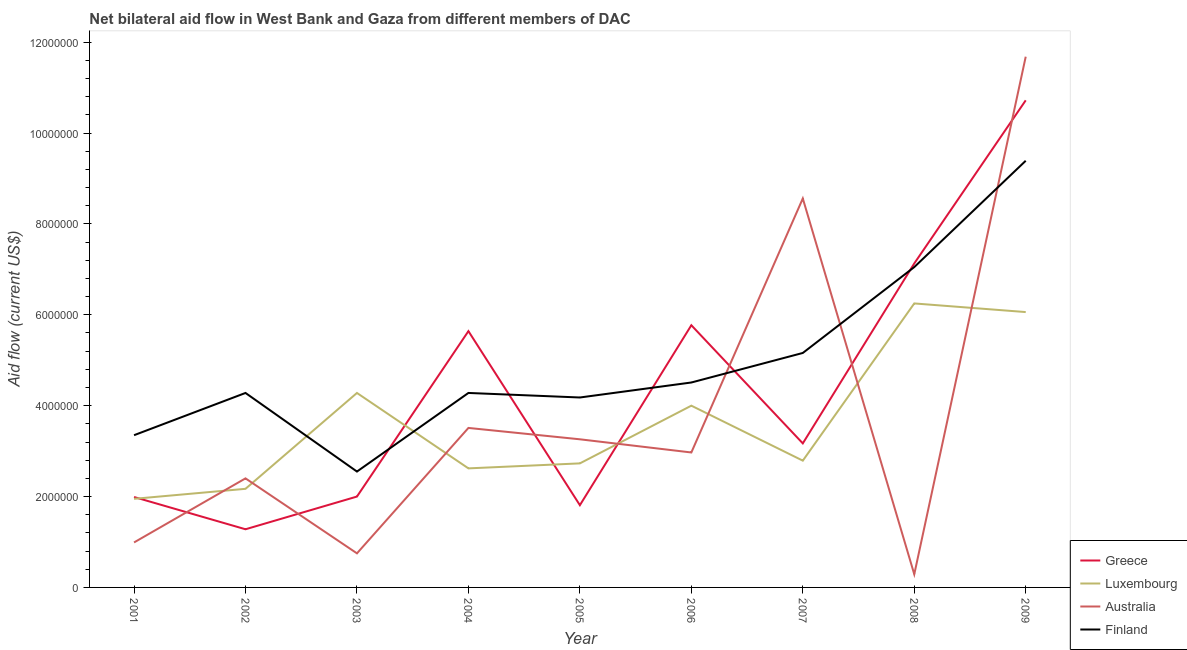How many different coloured lines are there?
Offer a terse response. 4. Does the line corresponding to amount of aid given by australia intersect with the line corresponding to amount of aid given by finland?
Offer a very short reply. Yes. What is the amount of aid given by greece in 2003?
Make the answer very short. 2.00e+06. Across all years, what is the maximum amount of aid given by australia?
Ensure brevity in your answer.  1.17e+07. Across all years, what is the minimum amount of aid given by finland?
Provide a succinct answer. 2.55e+06. In which year was the amount of aid given by finland minimum?
Offer a terse response. 2003. What is the total amount of aid given by australia in the graph?
Provide a succinct answer. 3.44e+07. What is the difference between the amount of aid given by finland in 2005 and that in 2007?
Keep it short and to the point. -9.80e+05. What is the difference between the amount of aid given by luxembourg in 2002 and the amount of aid given by greece in 2003?
Your answer should be very brief. 1.70e+05. What is the average amount of aid given by greece per year?
Offer a terse response. 4.39e+06. In the year 2009, what is the difference between the amount of aid given by finland and amount of aid given by greece?
Offer a very short reply. -1.33e+06. What is the ratio of the amount of aid given by finland in 2003 to that in 2008?
Give a very brief answer. 0.36. Is the amount of aid given by australia in 2004 less than that in 2009?
Provide a short and direct response. Yes. Is the difference between the amount of aid given by finland in 2002 and 2007 greater than the difference between the amount of aid given by australia in 2002 and 2007?
Your answer should be very brief. Yes. What is the difference between the highest and the second highest amount of aid given by luxembourg?
Your response must be concise. 1.90e+05. What is the difference between the highest and the lowest amount of aid given by greece?
Ensure brevity in your answer.  9.44e+06. Is it the case that in every year, the sum of the amount of aid given by greece and amount of aid given by luxembourg is greater than the amount of aid given by australia?
Your response must be concise. No. Is the amount of aid given by australia strictly greater than the amount of aid given by luxembourg over the years?
Provide a succinct answer. No. Is the amount of aid given by luxembourg strictly less than the amount of aid given by australia over the years?
Your answer should be compact. No. What is the difference between two consecutive major ticks on the Y-axis?
Offer a terse response. 2.00e+06. How many legend labels are there?
Ensure brevity in your answer.  4. How are the legend labels stacked?
Keep it short and to the point. Vertical. What is the title of the graph?
Ensure brevity in your answer.  Net bilateral aid flow in West Bank and Gaza from different members of DAC. What is the Aid flow (current US$) in Greece in 2001?
Provide a short and direct response. 1.99e+06. What is the Aid flow (current US$) in Luxembourg in 2001?
Offer a terse response. 1.95e+06. What is the Aid flow (current US$) of Australia in 2001?
Offer a very short reply. 9.90e+05. What is the Aid flow (current US$) in Finland in 2001?
Provide a succinct answer. 3.35e+06. What is the Aid flow (current US$) of Greece in 2002?
Provide a short and direct response. 1.28e+06. What is the Aid flow (current US$) of Luxembourg in 2002?
Keep it short and to the point. 2.17e+06. What is the Aid flow (current US$) in Australia in 2002?
Keep it short and to the point. 2.40e+06. What is the Aid flow (current US$) of Finland in 2002?
Keep it short and to the point. 4.28e+06. What is the Aid flow (current US$) of Luxembourg in 2003?
Your answer should be very brief. 4.28e+06. What is the Aid flow (current US$) in Australia in 2003?
Provide a succinct answer. 7.50e+05. What is the Aid flow (current US$) of Finland in 2003?
Your answer should be compact. 2.55e+06. What is the Aid flow (current US$) of Greece in 2004?
Your answer should be compact. 5.64e+06. What is the Aid flow (current US$) of Luxembourg in 2004?
Your answer should be compact. 2.62e+06. What is the Aid flow (current US$) in Australia in 2004?
Make the answer very short. 3.51e+06. What is the Aid flow (current US$) of Finland in 2004?
Ensure brevity in your answer.  4.28e+06. What is the Aid flow (current US$) of Greece in 2005?
Give a very brief answer. 1.81e+06. What is the Aid flow (current US$) in Luxembourg in 2005?
Your response must be concise. 2.73e+06. What is the Aid flow (current US$) in Australia in 2005?
Provide a succinct answer. 3.26e+06. What is the Aid flow (current US$) of Finland in 2005?
Give a very brief answer. 4.18e+06. What is the Aid flow (current US$) of Greece in 2006?
Provide a short and direct response. 5.77e+06. What is the Aid flow (current US$) in Luxembourg in 2006?
Provide a succinct answer. 4.00e+06. What is the Aid flow (current US$) of Australia in 2006?
Give a very brief answer. 2.97e+06. What is the Aid flow (current US$) of Finland in 2006?
Your answer should be compact. 4.51e+06. What is the Aid flow (current US$) of Greece in 2007?
Give a very brief answer. 3.17e+06. What is the Aid flow (current US$) of Luxembourg in 2007?
Offer a terse response. 2.79e+06. What is the Aid flow (current US$) of Australia in 2007?
Keep it short and to the point. 8.56e+06. What is the Aid flow (current US$) of Finland in 2007?
Provide a succinct answer. 5.16e+06. What is the Aid flow (current US$) in Greece in 2008?
Your response must be concise. 7.13e+06. What is the Aid flow (current US$) of Luxembourg in 2008?
Keep it short and to the point. 6.25e+06. What is the Aid flow (current US$) of Finland in 2008?
Your response must be concise. 7.05e+06. What is the Aid flow (current US$) of Greece in 2009?
Ensure brevity in your answer.  1.07e+07. What is the Aid flow (current US$) in Luxembourg in 2009?
Make the answer very short. 6.06e+06. What is the Aid flow (current US$) in Australia in 2009?
Give a very brief answer. 1.17e+07. What is the Aid flow (current US$) in Finland in 2009?
Keep it short and to the point. 9.39e+06. Across all years, what is the maximum Aid flow (current US$) of Greece?
Your response must be concise. 1.07e+07. Across all years, what is the maximum Aid flow (current US$) of Luxembourg?
Provide a succinct answer. 6.25e+06. Across all years, what is the maximum Aid flow (current US$) in Australia?
Your response must be concise. 1.17e+07. Across all years, what is the maximum Aid flow (current US$) in Finland?
Your response must be concise. 9.39e+06. Across all years, what is the minimum Aid flow (current US$) of Greece?
Your response must be concise. 1.28e+06. Across all years, what is the minimum Aid flow (current US$) in Luxembourg?
Provide a short and direct response. 1.95e+06. Across all years, what is the minimum Aid flow (current US$) of Finland?
Your answer should be compact. 2.55e+06. What is the total Aid flow (current US$) in Greece in the graph?
Your answer should be compact. 3.95e+07. What is the total Aid flow (current US$) in Luxembourg in the graph?
Make the answer very short. 3.28e+07. What is the total Aid flow (current US$) in Australia in the graph?
Your answer should be compact. 3.44e+07. What is the total Aid flow (current US$) of Finland in the graph?
Ensure brevity in your answer.  4.48e+07. What is the difference between the Aid flow (current US$) of Greece in 2001 and that in 2002?
Give a very brief answer. 7.10e+05. What is the difference between the Aid flow (current US$) in Luxembourg in 2001 and that in 2002?
Ensure brevity in your answer.  -2.20e+05. What is the difference between the Aid flow (current US$) in Australia in 2001 and that in 2002?
Offer a terse response. -1.41e+06. What is the difference between the Aid flow (current US$) of Finland in 2001 and that in 2002?
Keep it short and to the point. -9.30e+05. What is the difference between the Aid flow (current US$) in Luxembourg in 2001 and that in 2003?
Give a very brief answer. -2.33e+06. What is the difference between the Aid flow (current US$) in Greece in 2001 and that in 2004?
Your answer should be very brief. -3.65e+06. What is the difference between the Aid flow (current US$) of Luxembourg in 2001 and that in 2004?
Provide a succinct answer. -6.70e+05. What is the difference between the Aid flow (current US$) in Australia in 2001 and that in 2004?
Ensure brevity in your answer.  -2.52e+06. What is the difference between the Aid flow (current US$) in Finland in 2001 and that in 2004?
Provide a short and direct response. -9.30e+05. What is the difference between the Aid flow (current US$) in Greece in 2001 and that in 2005?
Make the answer very short. 1.80e+05. What is the difference between the Aid flow (current US$) of Luxembourg in 2001 and that in 2005?
Provide a succinct answer. -7.80e+05. What is the difference between the Aid flow (current US$) in Australia in 2001 and that in 2005?
Ensure brevity in your answer.  -2.27e+06. What is the difference between the Aid flow (current US$) of Finland in 2001 and that in 2005?
Ensure brevity in your answer.  -8.30e+05. What is the difference between the Aid flow (current US$) of Greece in 2001 and that in 2006?
Offer a very short reply. -3.78e+06. What is the difference between the Aid flow (current US$) in Luxembourg in 2001 and that in 2006?
Give a very brief answer. -2.05e+06. What is the difference between the Aid flow (current US$) in Australia in 2001 and that in 2006?
Keep it short and to the point. -1.98e+06. What is the difference between the Aid flow (current US$) of Finland in 2001 and that in 2006?
Make the answer very short. -1.16e+06. What is the difference between the Aid flow (current US$) of Greece in 2001 and that in 2007?
Your response must be concise. -1.18e+06. What is the difference between the Aid flow (current US$) in Luxembourg in 2001 and that in 2007?
Your response must be concise. -8.40e+05. What is the difference between the Aid flow (current US$) in Australia in 2001 and that in 2007?
Your answer should be very brief. -7.57e+06. What is the difference between the Aid flow (current US$) in Finland in 2001 and that in 2007?
Offer a terse response. -1.81e+06. What is the difference between the Aid flow (current US$) of Greece in 2001 and that in 2008?
Offer a very short reply. -5.14e+06. What is the difference between the Aid flow (current US$) of Luxembourg in 2001 and that in 2008?
Offer a terse response. -4.30e+06. What is the difference between the Aid flow (current US$) of Finland in 2001 and that in 2008?
Your response must be concise. -3.70e+06. What is the difference between the Aid flow (current US$) in Greece in 2001 and that in 2009?
Provide a succinct answer. -8.73e+06. What is the difference between the Aid flow (current US$) of Luxembourg in 2001 and that in 2009?
Your response must be concise. -4.11e+06. What is the difference between the Aid flow (current US$) of Australia in 2001 and that in 2009?
Provide a short and direct response. -1.07e+07. What is the difference between the Aid flow (current US$) of Finland in 2001 and that in 2009?
Keep it short and to the point. -6.04e+06. What is the difference between the Aid flow (current US$) in Greece in 2002 and that in 2003?
Offer a terse response. -7.20e+05. What is the difference between the Aid flow (current US$) in Luxembourg in 2002 and that in 2003?
Make the answer very short. -2.11e+06. What is the difference between the Aid flow (current US$) in Australia in 2002 and that in 2003?
Provide a succinct answer. 1.65e+06. What is the difference between the Aid flow (current US$) in Finland in 2002 and that in 2003?
Keep it short and to the point. 1.73e+06. What is the difference between the Aid flow (current US$) of Greece in 2002 and that in 2004?
Your answer should be very brief. -4.36e+06. What is the difference between the Aid flow (current US$) of Luxembourg in 2002 and that in 2004?
Provide a short and direct response. -4.50e+05. What is the difference between the Aid flow (current US$) in Australia in 2002 and that in 2004?
Your answer should be very brief. -1.11e+06. What is the difference between the Aid flow (current US$) in Greece in 2002 and that in 2005?
Ensure brevity in your answer.  -5.30e+05. What is the difference between the Aid flow (current US$) in Luxembourg in 2002 and that in 2005?
Make the answer very short. -5.60e+05. What is the difference between the Aid flow (current US$) of Australia in 2002 and that in 2005?
Your answer should be very brief. -8.60e+05. What is the difference between the Aid flow (current US$) of Greece in 2002 and that in 2006?
Your answer should be very brief. -4.49e+06. What is the difference between the Aid flow (current US$) of Luxembourg in 2002 and that in 2006?
Provide a succinct answer. -1.83e+06. What is the difference between the Aid flow (current US$) in Australia in 2002 and that in 2006?
Make the answer very short. -5.70e+05. What is the difference between the Aid flow (current US$) of Greece in 2002 and that in 2007?
Keep it short and to the point. -1.89e+06. What is the difference between the Aid flow (current US$) in Luxembourg in 2002 and that in 2007?
Your answer should be very brief. -6.20e+05. What is the difference between the Aid flow (current US$) in Australia in 2002 and that in 2007?
Keep it short and to the point. -6.16e+06. What is the difference between the Aid flow (current US$) of Finland in 2002 and that in 2007?
Your answer should be very brief. -8.80e+05. What is the difference between the Aid flow (current US$) in Greece in 2002 and that in 2008?
Give a very brief answer. -5.85e+06. What is the difference between the Aid flow (current US$) in Luxembourg in 2002 and that in 2008?
Give a very brief answer. -4.08e+06. What is the difference between the Aid flow (current US$) in Australia in 2002 and that in 2008?
Provide a succinct answer. 2.11e+06. What is the difference between the Aid flow (current US$) of Finland in 2002 and that in 2008?
Provide a succinct answer. -2.77e+06. What is the difference between the Aid flow (current US$) in Greece in 2002 and that in 2009?
Make the answer very short. -9.44e+06. What is the difference between the Aid flow (current US$) of Luxembourg in 2002 and that in 2009?
Give a very brief answer. -3.89e+06. What is the difference between the Aid flow (current US$) of Australia in 2002 and that in 2009?
Keep it short and to the point. -9.28e+06. What is the difference between the Aid flow (current US$) of Finland in 2002 and that in 2009?
Your answer should be very brief. -5.11e+06. What is the difference between the Aid flow (current US$) of Greece in 2003 and that in 2004?
Offer a very short reply. -3.64e+06. What is the difference between the Aid flow (current US$) in Luxembourg in 2003 and that in 2004?
Provide a short and direct response. 1.66e+06. What is the difference between the Aid flow (current US$) of Australia in 2003 and that in 2004?
Offer a very short reply. -2.76e+06. What is the difference between the Aid flow (current US$) in Finland in 2003 and that in 2004?
Offer a very short reply. -1.73e+06. What is the difference between the Aid flow (current US$) of Luxembourg in 2003 and that in 2005?
Your answer should be compact. 1.55e+06. What is the difference between the Aid flow (current US$) of Australia in 2003 and that in 2005?
Provide a short and direct response. -2.51e+06. What is the difference between the Aid flow (current US$) in Finland in 2003 and that in 2005?
Keep it short and to the point. -1.63e+06. What is the difference between the Aid flow (current US$) of Greece in 2003 and that in 2006?
Keep it short and to the point. -3.77e+06. What is the difference between the Aid flow (current US$) in Luxembourg in 2003 and that in 2006?
Your answer should be compact. 2.80e+05. What is the difference between the Aid flow (current US$) in Australia in 2003 and that in 2006?
Your response must be concise. -2.22e+06. What is the difference between the Aid flow (current US$) in Finland in 2003 and that in 2006?
Offer a very short reply. -1.96e+06. What is the difference between the Aid flow (current US$) in Greece in 2003 and that in 2007?
Your answer should be compact. -1.17e+06. What is the difference between the Aid flow (current US$) of Luxembourg in 2003 and that in 2007?
Your answer should be compact. 1.49e+06. What is the difference between the Aid flow (current US$) of Australia in 2003 and that in 2007?
Your answer should be very brief. -7.81e+06. What is the difference between the Aid flow (current US$) in Finland in 2003 and that in 2007?
Ensure brevity in your answer.  -2.61e+06. What is the difference between the Aid flow (current US$) of Greece in 2003 and that in 2008?
Provide a short and direct response. -5.13e+06. What is the difference between the Aid flow (current US$) of Luxembourg in 2003 and that in 2008?
Ensure brevity in your answer.  -1.97e+06. What is the difference between the Aid flow (current US$) in Australia in 2003 and that in 2008?
Provide a short and direct response. 4.60e+05. What is the difference between the Aid flow (current US$) of Finland in 2003 and that in 2008?
Keep it short and to the point. -4.50e+06. What is the difference between the Aid flow (current US$) in Greece in 2003 and that in 2009?
Offer a very short reply. -8.72e+06. What is the difference between the Aid flow (current US$) of Luxembourg in 2003 and that in 2009?
Provide a succinct answer. -1.78e+06. What is the difference between the Aid flow (current US$) of Australia in 2003 and that in 2009?
Give a very brief answer. -1.09e+07. What is the difference between the Aid flow (current US$) of Finland in 2003 and that in 2009?
Your response must be concise. -6.84e+06. What is the difference between the Aid flow (current US$) in Greece in 2004 and that in 2005?
Offer a terse response. 3.83e+06. What is the difference between the Aid flow (current US$) of Australia in 2004 and that in 2005?
Your answer should be very brief. 2.50e+05. What is the difference between the Aid flow (current US$) in Finland in 2004 and that in 2005?
Offer a terse response. 1.00e+05. What is the difference between the Aid flow (current US$) of Greece in 2004 and that in 2006?
Ensure brevity in your answer.  -1.30e+05. What is the difference between the Aid flow (current US$) in Luxembourg in 2004 and that in 2006?
Ensure brevity in your answer.  -1.38e+06. What is the difference between the Aid flow (current US$) in Australia in 2004 and that in 2006?
Offer a very short reply. 5.40e+05. What is the difference between the Aid flow (current US$) in Finland in 2004 and that in 2006?
Keep it short and to the point. -2.30e+05. What is the difference between the Aid flow (current US$) of Greece in 2004 and that in 2007?
Ensure brevity in your answer.  2.47e+06. What is the difference between the Aid flow (current US$) in Luxembourg in 2004 and that in 2007?
Your answer should be compact. -1.70e+05. What is the difference between the Aid flow (current US$) in Australia in 2004 and that in 2007?
Offer a terse response. -5.05e+06. What is the difference between the Aid flow (current US$) of Finland in 2004 and that in 2007?
Provide a succinct answer. -8.80e+05. What is the difference between the Aid flow (current US$) of Greece in 2004 and that in 2008?
Keep it short and to the point. -1.49e+06. What is the difference between the Aid flow (current US$) of Luxembourg in 2004 and that in 2008?
Your answer should be very brief. -3.63e+06. What is the difference between the Aid flow (current US$) of Australia in 2004 and that in 2008?
Provide a short and direct response. 3.22e+06. What is the difference between the Aid flow (current US$) of Finland in 2004 and that in 2008?
Provide a succinct answer. -2.77e+06. What is the difference between the Aid flow (current US$) in Greece in 2004 and that in 2009?
Ensure brevity in your answer.  -5.08e+06. What is the difference between the Aid flow (current US$) in Luxembourg in 2004 and that in 2009?
Provide a short and direct response. -3.44e+06. What is the difference between the Aid flow (current US$) of Australia in 2004 and that in 2009?
Offer a very short reply. -8.17e+06. What is the difference between the Aid flow (current US$) of Finland in 2004 and that in 2009?
Offer a very short reply. -5.11e+06. What is the difference between the Aid flow (current US$) in Greece in 2005 and that in 2006?
Your answer should be compact. -3.96e+06. What is the difference between the Aid flow (current US$) of Luxembourg in 2005 and that in 2006?
Offer a terse response. -1.27e+06. What is the difference between the Aid flow (current US$) in Finland in 2005 and that in 2006?
Provide a succinct answer. -3.30e+05. What is the difference between the Aid flow (current US$) of Greece in 2005 and that in 2007?
Offer a terse response. -1.36e+06. What is the difference between the Aid flow (current US$) in Luxembourg in 2005 and that in 2007?
Your answer should be compact. -6.00e+04. What is the difference between the Aid flow (current US$) of Australia in 2005 and that in 2007?
Provide a succinct answer. -5.30e+06. What is the difference between the Aid flow (current US$) in Finland in 2005 and that in 2007?
Your answer should be very brief. -9.80e+05. What is the difference between the Aid flow (current US$) of Greece in 2005 and that in 2008?
Give a very brief answer. -5.32e+06. What is the difference between the Aid flow (current US$) of Luxembourg in 2005 and that in 2008?
Make the answer very short. -3.52e+06. What is the difference between the Aid flow (current US$) of Australia in 2005 and that in 2008?
Offer a very short reply. 2.97e+06. What is the difference between the Aid flow (current US$) of Finland in 2005 and that in 2008?
Offer a terse response. -2.87e+06. What is the difference between the Aid flow (current US$) in Greece in 2005 and that in 2009?
Give a very brief answer. -8.91e+06. What is the difference between the Aid flow (current US$) of Luxembourg in 2005 and that in 2009?
Make the answer very short. -3.33e+06. What is the difference between the Aid flow (current US$) of Australia in 2005 and that in 2009?
Offer a very short reply. -8.42e+06. What is the difference between the Aid flow (current US$) in Finland in 2005 and that in 2009?
Offer a terse response. -5.21e+06. What is the difference between the Aid flow (current US$) in Greece in 2006 and that in 2007?
Your answer should be compact. 2.60e+06. What is the difference between the Aid flow (current US$) of Luxembourg in 2006 and that in 2007?
Your response must be concise. 1.21e+06. What is the difference between the Aid flow (current US$) in Australia in 2006 and that in 2007?
Your answer should be very brief. -5.59e+06. What is the difference between the Aid flow (current US$) of Finland in 2006 and that in 2007?
Your response must be concise. -6.50e+05. What is the difference between the Aid flow (current US$) in Greece in 2006 and that in 2008?
Your response must be concise. -1.36e+06. What is the difference between the Aid flow (current US$) in Luxembourg in 2006 and that in 2008?
Give a very brief answer. -2.25e+06. What is the difference between the Aid flow (current US$) in Australia in 2006 and that in 2008?
Your response must be concise. 2.68e+06. What is the difference between the Aid flow (current US$) of Finland in 2006 and that in 2008?
Provide a succinct answer. -2.54e+06. What is the difference between the Aid flow (current US$) of Greece in 2006 and that in 2009?
Make the answer very short. -4.95e+06. What is the difference between the Aid flow (current US$) of Luxembourg in 2006 and that in 2009?
Keep it short and to the point. -2.06e+06. What is the difference between the Aid flow (current US$) in Australia in 2006 and that in 2009?
Ensure brevity in your answer.  -8.71e+06. What is the difference between the Aid flow (current US$) in Finland in 2006 and that in 2009?
Your response must be concise. -4.88e+06. What is the difference between the Aid flow (current US$) of Greece in 2007 and that in 2008?
Your answer should be compact. -3.96e+06. What is the difference between the Aid flow (current US$) in Luxembourg in 2007 and that in 2008?
Provide a short and direct response. -3.46e+06. What is the difference between the Aid flow (current US$) of Australia in 2007 and that in 2008?
Give a very brief answer. 8.27e+06. What is the difference between the Aid flow (current US$) in Finland in 2007 and that in 2008?
Keep it short and to the point. -1.89e+06. What is the difference between the Aid flow (current US$) of Greece in 2007 and that in 2009?
Ensure brevity in your answer.  -7.55e+06. What is the difference between the Aid flow (current US$) in Luxembourg in 2007 and that in 2009?
Your answer should be very brief. -3.27e+06. What is the difference between the Aid flow (current US$) of Australia in 2007 and that in 2009?
Give a very brief answer. -3.12e+06. What is the difference between the Aid flow (current US$) in Finland in 2007 and that in 2009?
Give a very brief answer. -4.23e+06. What is the difference between the Aid flow (current US$) in Greece in 2008 and that in 2009?
Offer a terse response. -3.59e+06. What is the difference between the Aid flow (current US$) in Luxembourg in 2008 and that in 2009?
Make the answer very short. 1.90e+05. What is the difference between the Aid flow (current US$) of Australia in 2008 and that in 2009?
Provide a succinct answer. -1.14e+07. What is the difference between the Aid flow (current US$) of Finland in 2008 and that in 2009?
Provide a short and direct response. -2.34e+06. What is the difference between the Aid flow (current US$) of Greece in 2001 and the Aid flow (current US$) of Luxembourg in 2002?
Ensure brevity in your answer.  -1.80e+05. What is the difference between the Aid flow (current US$) in Greece in 2001 and the Aid flow (current US$) in Australia in 2002?
Provide a short and direct response. -4.10e+05. What is the difference between the Aid flow (current US$) of Greece in 2001 and the Aid flow (current US$) of Finland in 2002?
Your answer should be very brief. -2.29e+06. What is the difference between the Aid flow (current US$) of Luxembourg in 2001 and the Aid flow (current US$) of Australia in 2002?
Keep it short and to the point. -4.50e+05. What is the difference between the Aid flow (current US$) in Luxembourg in 2001 and the Aid flow (current US$) in Finland in 2002?
Offer a terse response. -2.33e+06. What is the difference between the Aid flow (current US$) of Australia in 2001 and the Aid flow (current US$) of Finland in 2002?
Keep it short and to the point. -3.29e+06. What is the difference between the Aid flow (current US$) of Greece in 2001 and the Aid flow (current US$) of Luxembourg in 2003?
Provide a succinct answer. -2.29e+06. What is the difference between the Aid flow (current US$) of Greece in 2001 and the Aid flow (current US$) of Australia in 2003?
Keep it short and to the point. 1.24e+06. What is the difference between the Aid flow (current US$) in Greece in 2001 and the Aid flow (current US$) in Finland in 2003?
Provide a succinct answer. -5.60e+05. What is the difference between the Aid flow (current US$) of Luxembourg in 2001 and the Aid flow (current US$) of Australia in 2003?
Your answer should be compact. 1.20e+06. What is the difference between the Aid flow (current US$) of Luxembourg in 2001 and the Aid flow (current US$) of Finland in 2003?
Keep it short and to the point. -6.00e+05. What is the difference between the Aid flow (current US$) of Australia in 2001 and the Aid flow (current US$) of Finland in 2003?
Provide a succinct answer. -1.56e+06. What is the difference between the Aid flow (current US$) in Greece in 2001 and the Aid flow (current US$) in Luxembourg in 2004?
Offer a very short reply. -6.30e+05. What is the difference between the Aid flow (current US$) in Greece in 2001 and the Aid flow (current US$) in Australia in 2004?
Keep it short and to the point. -1.52e+06. What is the difference between the Aid flow (current US$) in Greece in 2001 and the Aid flow (current US$) in Finland in 2004?
Keep it short and to the point. -2.29e+06. What is the difference between the Aid flow (current US$) in Luxembourg in 2001 and the Aid flow (current US$) in Australia in 2004?
Keep it short and to the point. -1.56e+06. What is the difference between the Aid flow (current US$) in Luxembourg in 2001 and the Aid flow (current US$) in Finland in 2004?
Give a very brief answer. -2.33e+06. What is the difference between the Aid flow (current US$) of Australia in 2001 and the Aid flow (current US$) of Finland in 2004?
Keep it short and to the point. -3.29e+06. What is the difference between the Aid flow (current US$) in Greece in 2001 and the Aid flow (current US$) in Luxembourg in 2005?
Offer a terse response. -7.40e+05. What is the difference between the Aid flow (current US$) in Greece in 2001 and the Aid flow (current US$) in Australia in 2005?
Your response must be concise. -1.27e+06. What is the difference between the Aid flow (current US$) in Greece in 2001 and the Aid flow (current US$) in Finland in 2005?
Your answer should be very brief. -2.19e+06. What is the difference between the Aid flow (current US$) in Luxembourg in 2001 and the Aid flow (current US$) in Australia in 2005?
Offer a terse response. -1.31e+06. What is the difference between the Aid flow (current US$) in Luxembourg in 2001 and the Aid flow (current US$) in Finland in 2005?
Provide a short and direct response. -2.23e+06. What is the difference between the Aid flow (current US$) of Australia in 2001 and the Aid flow (current US$) of Finland in 2005?
Offer a very short reply. -3.19e+06. What is the difference between the Aid flow (current US$) in Greece in 2001 and the Aid flow (current US$) in Luxembourg in 2006?
Provide a short and direct response. -2.01e+06. What is the difference between the Aid flow (current US$) in Greece in 2001 and the Aid flow (current US$) in Australia in 2006?
Provide a short and direct response. -9.80e+05. What is the difference between the Aid flow (current US$) of Greece in 2001 and the Aid flow (current US$) of Finland in 2006?
Offer a terse response. -2.52e+06. What is the difference between the Aid flow (current US$) of Luxembourg in 2001 and the Aid flow (current US$) of Australia in 2006?
Offer a very short reply. -1.02e+06. What is the difference between the Aid flow (current US$) in Luxembourg in 2001 and the Aid flow (current US$) in Finland in 2006?
Offer a terse response. -2.56e+06. What is the difference between the Aid flow (current US$) in Australia in 2001 and the Aid flow (current US$) in Finland in 2006?
Offer a very short reply. -3.52e+06. What is the difference between the Aid flow (current US$) in Greece in 2001 and the Aid flow (current US$) in Luxembourg in 2007?
Ensure brevity in your answer.  -8.00e+05. What is the difference between the Aid flow (current US$) in Greece in 2001 and the Aid flow (current US$) in Australia in 2007?
Offer a very short reply. -6.57e+06. What is the difference between the Aid flow (current US$) of Greece in 2001 and the Aid flow (current US$) of Finland in 2007?
Keep it short and to the point. -3.17e+06. What is the difference between the Aid flow (current US$) of Luxembourg in 2001 and the Aid flow (current US$) of Australia in 2007?
Make the answer very short. -6.61e+06. What is the difference between the Aid flow (current US$) of Luxembourg in 2001 and the Aid flow (current US$) of Finland in 2007?
Offer a terse response. -3.21e+06. What is the difference between the Aid flow (current US$) of Australia in 2001 and the Aid flow (current US$) of Finland in 2007?
Your answer should be compact. -4.17e+06. What is the difference between the Aid flow (current US$) in Greece in 2001 and the Aid flow (current US$) in Luxembourg in 2008?
Provide a short and direct response. -4.26e+06. What is the difference between the Aid flow (current US$) in Greece in 2001 and the Aid flow (current US$) in Australia in 2008?
Offer a very short reply. 1.70e+06. What is the difference between the Aid flow (current US$) of Greece in 2001 and the Aid flow (current US$) of Finland in 2008?
Your answer should be compact. -5.06e+06. What is the difference between the Aid flow (current US$) in Luxembourg in 2001 and the Aid flow (current US$) in Australia in 2008?
Keep it short and to the point. 1.66e+06. What is the difference between the Aid flow (current US$) in Luxembourg in 2001 and the Aid flow (current US$) in Finland in 2008?
Give a very brief answer. -5.10e+06. What is the difference between the Aid flow (current US$) of Australia in 2001 and the Aid flow (current US$) of Finland in 2008?
Your answer should be compact. -6.06e+06. What is the difference between the Aid flow (current US$) of Greece in 2001 and the Aid flow (current US$) of Luxembourg in 2009?
Your response must be concise. -4.07e+06. What is the difference between the Aid flow (current US$) of Greece in 2001 and the Aid flow (current US$) of Australia in 2009?
Give a very brief answer. -9.69e+06. What is the difference between the Aid flow (current US$) in Greece in 2001 and the Aid flow (current US$) in Finland in 2009?
Ensure brevity in your answer.  -7.40e+06. What is the difference between the Aid flow (current US$) in Luxembourg in 2001 and the Aid flow (current US$) in Australia in 2009?
Ensure brevity in your answer.  -9.73e+06. What is the difference between the Aid flow (current US$) in Luxembourg in 2001 and the Aid flow (current US$) in Finland in 2009?
Keep it short and to the point. -7.44e+06. What is the difference between the Aid flow (current US$) in Australia in 2001 and the Aid flow (current US$) in Finland in 2009?
Give a very brief answer. -8.40e+06. What is the difference between the Aid flow (current US$) of Greece in 2002 and the Aid flow (current US$) of Luxembourg in 2003?
Give a very brief answer. -3.00e+06. What is the difference between the Aid flow (current US$) of Greece in 2002 and the Aid flow (current US$) of Australia in 2003?
Your response must be concise. 5.30e+05. What is the difference between the Aid flow (current US$) of Greece in 2002 and the Aid flow (current US$) of Finland in 2003?
Your answer should be compact. -1.27e+06. What is the difference between the Aid flow (current US$) in Luxembourg in 2002 and the Aid flow (current US$) in Australia in 2003?
Ensure brevity in your answer.  1.42e+06. What is the difference between the Aid flow (current US$) of Luxembourg in 2002 and the Aid flow (current US$) of Finland in 2003?
Provide a succinct answer. -3.80e+05. What is the difference between the Aid flow (current US$) of Greece in 2002 and the Aid flow (current US$) of Luxembourg in 2004?
Offer a terse response. -1.34e+06. What is the difference between the Aid flow (current US$) in Greece in 2002 and the Aid flow (current US$) in Australia in 2004?
Provide a short and direct response. -2.23e+06. What is the difference between the Aid flow (current US$) of Luxembourg in 2002 and the Aid flow (current US$) of Australia in 2004?
Offer a terse response. -1.34e+06. What is the difference between the Aid flow (current US$) in Luxembourg in 2002 and the Aid flow (current US$) in Finland in 2004?
Your response must be concise. -2.11e+06. What is the difference between the Aid flow (current US$) in Australia in 2002 and the Aid flow (current US$) in Finland in 2004?
Give a very brief answer. -1.88e+06. What is the difference between the Aid flow (current US$) in Greece in 2002 and the Aid flow (current US$) in Luxembourg in 2005?
Your answer should be compact. -1.45e+06. What is the difference between the Aid flow (current US$) of Greece in 2002 and the Aid flow (current US$) of Australia in 2005?
Provide a succinct answer. -1.98e+06. What is the difference between the Aid flow (current US$) of Greece in 2002 and the Aid flow (current US$) of Finland in 2005?
Offer a terse response. -2.90e+06. What is the difference between the Aid flow (current US$) in Luxembourg in 2002 and the Aid flow (current US$) in Australia in 2005?
Offer a very short reply. -1.09e+06. What is the difference between the Aid flow (current US$) of Luxembourg in 2002 and the Aid flow (current US$) of Finland in 2005?
Keep it short and to the point. -2.01e+06. What is the difference between the Aid flow (current US$) of Australia in 2002 and the Aid flow (current US$) of Finland in 2005?
Your answer should be very brief. -1.78e+06. What is the difference between the Aid flow (current US$) of Greece in 2002 and the Aid flow (current US$) of Luxembourg in 2006?
Offer a terse response. -2.72e+06. What is the difference between the Aid flow (current US$) of Greece in 2002 and the Aid flow (current US$) of Australia in 2006?
Offer a terse response. -1.69e+06. What is the difference between the Aid flow (current US$) in Greece in 2002 and the Aid flow (current US$) in Finland in 2006?
Ensure brevity in your answer.  -3.23e+06. What is the difference between the Aid flow (current US$) of Luxembourg in 2002 and the Aid flow (current US$) of Australia in 2006?
Your answer should be very brief. -8.00e+05. What is the difference between the Aid flow (current US$) of Luxembourg in 2002 and the Aid flow (current US$) of Finland in 2006?
Provide a succinct answer. -2.34e+06. What is the difference between the Aid flow (current US$) of Australia in 2002 and the Aid flow (current US$) of Finland in 2006?
Offer a very short reply. -2.11e+06. What is the difference between the Aid flow (current US$) in Greece in 2002 and the Aid flow (current US$) in Luxembourg in 2007?
Provide a short and direct response. -1.51e+06. What is the difference between the Aid flow (current US$) in Greece in 2002 and the Aid flow (current US$) in Australia in 2007?
Provide a succinct answer. -7.28e+06. What is the difference between the Aid flow (current US$) of Greece in 2002 and the Aid flow (current US$) of Finland in 2007?
Offer a terse response. -3.88e+06. What is the difference between the Aid flow (current US$) of Luxembourg in 2002 and the Aid flow (current US$) of Australia in 2007?
Provide a succinct answer. -6.39e+06. What is the difference between the Aid flow (current US$) in Luxembourg in 2002 and the Aid flow (current US$) in Finland in 2007?
Your response must be concise. -2.99e+06. What is the difference between the Aid flow (current US$) of Australia in 2002 and the Aid flow (current US$) of Finland in 2007?
Offer a very short reply. -2.76e+06. What is the difference between the Aid flow (current US$) in Greece in 2002 and the Aid flow (current US$) in Luxembourg in 2008?
Your answer should be compact. -4.97e+06. What is the difference between the Aid flow (current US$) in Greece in 2002 and the Aid flow (current US$) in Australia in 2008?
Provide a short and direct response. 9.90e+05. What is the difference between the Aid flow (current US$) in Greece in 2002 and the Aid flow (current US$) in Finland in 2008?
Provide a short and direct response. -5.77e+06. What is the difference between the Aid flow (current US$) of Luxembourg in 2002 and the Aid flow (current US$) of Australia in 2008?
Provide a succinct answer. 1.88e+06. What is the difference between the Aid flow (current US$) in Luxembourg in 2002 and the Aid flow (current US$) in Finland in 2008?
Provide a short and direct response. -4.88e+06. What is the difference between the Aid flow (current US$) in Australia in 2002 and the Aid flow (current US$) in Finland in 2008?
Your answer should be compact. -4.65e+06. What is the difference between the Aid flow (current US$) of Greece in 2002 and the Aid flow (current US$) of Luxembourg in 2009?
Offer a terse response. -4.78e+06. What is the difference between the Aid flow (current US$) of Greece in 2002 and the Aid flow (current US$) of Australia in 2009?
Your answer should be very brief. -1.04e+07. What is the difference between the Aid flow (current US$) in Greece in 2002 and the Aid flow (current US$) in Finland in 2009?
Make the answer very short. -8.11e+06. What is the difference between the Aid flow (current US$) of Luxembourg in 2002 and the Aid flow (current US$) of Australia in 2009?
Give a very brief answer. -9.51e+06. What is the difference between the Aid flow (current US$) in Luxembourg in 2002 and the Aid flow (current US$) in Finland in 2009?
Keep it short and to the point. -7.22e+06. What is the difference between the Aid flow (current US$) of Australia in 2002 and the Aid flow (current US$) of Finland in 2009?
Keep it short and to the point. -6.99e+06. What is the difference between the Aid flow (current US$) in Greece in 2003 and the Aid flow (current US$) in Luxembourg in 2004?
Keep it short and to the point. -6.20e+05. What is the difference between the Aid flow (current US$) of Greece in 2003 and the Aid flow (current US$) of Australia in 2004?
Your answer should be very brief. -1.51e+06. What is the difference between the Aid flow (current US$) of Greece in 2003 and the Aid flow (current US$) of Finland in 2004?
Your answer should be very brief. -2.28e+06. What is the difference between the Aid flow (current US$) of Luxembourg in 2003 and the Aid flow (current US$) of Australia in 2004?
Provide a short and direct response. 7.70e+05. What is the difference between the Aid flow (current US$) of Australia in 2003 and the Aid flow (current US$) of Finland in 2004?
Offer a terse response. -3.53e+06. What is the difference between the Aid flow (current US$) in Greece in 2003 and the Aid flow (current US$) in Luxembourg in 2005?
Make the answer very short. -7.30e+05. What is the difference between the Aid flow (current US$) in Greece in 2003 and the Aid flow (current US$) in Australia in 2005?
Your response must be concise. -1.26e+06. What is the difference between the Aid flow (current US$) of Greece in 2003 and the Aid flow (current US$) of Finland in 2005?
Provide a short and direct response. -2.18e+06. What is the difference between the Aid flow (current US$) in Luxembourg in 2003 and the Aid flow (current US$) in Australia in 2005?
Offer a terse response. 1.02e+06. What is the difference between the Aid flow (current US$) in Luxembourg in 2003 and the Aid flow (current US$) in Finland in 2005?
Ensure brevity in your answer.  1.00e+05. What is the difference between the Aid flow (current US$) of Australia in 2003 and the Aid flow (current US$) of Finland in 2005?
Your answer should be compact. -3.43e+06. What is the difference between the Aid flow (current US$) in Greece in 2003 and the Aid flow (current US$) in Luxembourg in 2006?
Offer a terse response. -2.00e+06. What is the difference between the Aid flow (current US$) of Greece in 2003 and the Aid flow (current US$) of Australia in 2006?
Give a very brief answer. -9.70e+05. What is the difference between the Aid flow (current US$) in Greece in 2003 and the Aid flow (current US$) in Finland in 2006?
Ensure brevity in your answer.  -2.51e+06. What is the difference between the Aid flow (current US$) in Luxembourg in 2003 and the Aid flow (current US$) in Australia in 2006?
Give a very brief answer. 1.31e+06. What is the difference between the Aid flow (current US$) of Luxembourg in 2003 and the Aid flow (current US$) of Finland in 2006?
Offer a very short reply. -2.30e+05. What is the difference between the Aid flow (current US$) in Australia in 2003 and the Aid flow (current US$) in Finland in 2006?
Your answer should be compact. -3.76e+06. What is the difference between the Aid flow (current US$) of Greece in 2003 and the Aid flow (current US$) of Luxembourg in 2007?
Your answer should be very brief. -7.90e+05. What is the difference between the Aid flow (current US$) in Greece in 2003 and the Aid flow (current US$) in Australia in 2007?
Your answer should be compact. -6.56e+06. What is the difference between the Aid flow (current US$) of Greece in 2003 and the Aid flow (current US$) of Finland in 2007?
Your response must be concise. -3.16e+06. What is the difference between the Aid flow (current US$) of Luxembourg in 2003 and the Aid flow (current US$) of Australia in 2007?
Provide a short and direct response. -4.28e+06. What is the difference between the Aid flow (current US$) of Luxembourg in 2003 and the Aid flow (current US$) of Finland in 2007?
Ensure brevity in your answer.  -8.80e+05. What is the difference between the Aid flow (current US$) in Australia in 2003 and the Aid flow (current US$) in Finland in 2007?
Provide a short and direct response. -4.41e+06. What is the difference between the Aid flow (current US$) in Greece in 2003 and the Aid flow (current US$) in Luxembourg in 2008?
Offer a very short reply. -4.25e+06. What is the difference between the Aid flow (current US$) of Greece in 2003 and the Aid flow (current US$) of Australia in 2008?
Provide a succinct answer. 1.71e+06. What is the difference between the Aid flow (current US$) of Greece in 2003 and the Aid flow (current US$) of Finland in 2008?
Ensure brevity in your answer.  -5.05e+06. What is the difference between the Aid flow (current US$) in Luxembourg in 2003 and the Aid flow (current US$) in Australia in 2008?
Offer a terse response. 3.99e+06. What is the difference between the Aid flow (current US$) in Luxembourg in 2003 and the Aid flow (current US$) in Finland in 2008?
Your answer should be compact. -2.77e+06. What is the difference between the Aid flow (current US$) of Australia in 2003 and the Aid flow (current US$) of Finland in 2008?
Give a very brief answer. -6.30e+06. What is the difference between the Aid flow (current US$) in Greece in 2003 and the Aid flow (current US$) in Luxembourg in 2009?
Offer a terse response. -4.06e+06. What is the difference between the Aid flow (current US$) of Greece in 2003 and the Aid flow (current US$) of Australia in 2009?
Keep it short and to the point. -9.68e+06. What is the difference between the Aid flow (current US$) of Greece in 2003 and the Aid flow (current US$) of Finland in 2009?
Keep it short and to the point. -7.39e+06. What is the difference between the Aid flow (current US$) of Luxembourg in 2003 and the Aid flow (current US$) of Australia in 2009?
Offer a very short reply. -7.40e+06. What is the difference between the Aid flow (current US$) in Luxembourg in 2003 and the Aid flow (current US$) in Finland in 2009?
Your answer should be compact. -5.11e+06. What is the difference between the Aid flow (current US$) of Australia in 2003 and the Aid flow (current US$) of Finland in 2009?
Provide a short and direct response. -8.64e+06. What is the difference between the Aid flow (current US$) of Greece in 2004 and the Aid flow (current US$) of Luxembourg in 2005?
Give a very brief answer. 2.91e+06. What is the difference between the Aid flow (current US$) of Greece in 2004 and the Aid flow (current US$) of Australia in 2005?
Your answer should be compact. 2.38e+06. What is the difference between the Aid flow (current US$) in Greece in 2004 and the Aid flow (current US$) in Finland in 2005?
Offer a very short reply. 1.46e+06. What is the difference between the Aid flow (current US$) of Luxembourg in 2004 and the Aid flow (current US$) of Australia in 2005?
Make the answer very short. -6.40e+05. What is the difference between the Aid flow (current US$) of Luxembourg in 2004 and the Aid flow (current US$) of Finland in 2005?
Offer a terse response. -1.56e+06. What is the difference between the Aid flow (current US$) of Australia in 2004 and the Aid flow (current US$) of Finland in 2005?
Offer a terse response. -6.70e+05. What is the difference between the Aid flow (current US$) of Greece in 2004 and the Aid flow (current US$) of Luxembourg in 2006?
Offer a very short reply. 1.64e+06. What is the difference between the Aid flow (current US$) in Greece in 2004 and the Aid flow (current US$) in Australia in 2006?
Your answer should be compact. 2.67e+06. What is the difference between the Aid flow (current US$) in Greece in 2004 and the Aid flow (current US$) in Finland in 2006?
Give a very brief answer. 1.13e+06. What is the difference between the Aid flow (current US$) in Luxembourg in 2004 and the Aid flow (current US$) in Australia in 2006?
Ensure brevity in your answer.  -3.50e+05. What is the difference between the Aid flow (current US$) of Luxembourg in 2004 and the Aid flow (current US$) of Finland in 2006?
Your response must be concise. -1.89e+06. What is the difference between the Aid flow (current US$) of Australia in 2004 and the Aid flow (current US$) of Finland in 2006?
Your response must be concise. -1.00e+06. What is the difference between the Aid flow (current US$) of Greece in 2004 and the Aid flow (current US$) of Luxembourg in 2007?
Provide a succinct answer. 2.85e+06. What is the difference between the Aid flow (current US$) in Greece in 2004 and the Aid flow (current US$) in Australia in 2007?
Your response must be concise. -2.92e+06. What is the difference between the Aid flow (current US$) of Greece in 2004 and the Aid flow (current US$) of Finland in 2007?
Your answer should be very brief. 4.80e+05. What is the difference between the Aid flow (current US$) in Luxembourg in 2004 and the Aid flow (current US$) in Australia in 2007?
Your answer should be very brief. -5.94e+06. What is the difference between the Aid flow (current US$) of Luxembourg in 2004 and the Aid flow (current US$) of Finland in 2007?
Offer a very short reply. -2.54e+06. What is the difference between the Aid flow (current US$) of Australia in 2004 and the Aid flow (current US$) of Finland in 2007?
Your answer should be very brief. -1.65e+06. What is the difference between the Aid flow (current US$) in Greece in 2004 and the Aid flow (current US$) in Luxembourg in 2008?
Your answer should be compact. -6.10e+05. What is the difference between the Aid flow (current US$) in Greece in 2004 and the Aid flow (current US$) in Australia in 2008?
Give a very brief answer. 5.35e+06. What is the difference between the Aid flow (current US$) of Greece in 2004 and the Aid flow (current US$) of Finland in 2008?
Keep it short and to the point. -1.41e+06. What is the difference between the Aid flow (current US$) in Luxembourg in 2004 and the Aid flow (current US$) in Australia in 2008?
Offer a very short reply. 2.33e+06. What is the difference between the Aid flow (current US$) of Luxembourg in 2004 and the Aid flow (current US$) of Finland in 2008?
Make the answer very short. -4.43e+06. What is the difference between the Aid flow (current US$) in Australia in 2004 and the Aid flow (current US$) in Finland in 2008?
Your answer should be very brief. -3.54e+06. What is the difference between the Aid flow (current US$) in Greece in 2004 and the Aid flow (current US$) in Luxembourg in 2009?
Your response must be concise. -4.20e+05. What is the difference between the Aid flow (current US$) in Greece in 2004 and the Aid flow (current US$) in Australia in 2009?
Ensure brevity in your answer.  -6.04e+06. What is the difference between the Aid flow (current US$) of Greece in 2004 and the Aid flow (current US$) of Finland in 2009?
Offer a very short reply. -3.75e+06. What is the difference between the Aid flow (current US$) of Luxembourg in 2004 and the Aid flow (current US$) of Australia in 2009?
Provide a succinct answer. -9.06e+06. What is the difference between the Aid flow (current US$) in Luxembourg in 2004 and the Aid flow (current US$) in Finland in 2009?
Make the answer very short. -6.77e+06. What is the difference between the Aid flow (current US$) in Australia in 2004 and the Aid flow (current US$) in Finland in 2009?
Keep it short and to the point. -5.88e+06. What is the difference between the Aid flow (current US$) of Greece in 2005 and the Aid flow (current US$) of Luxembourg in 2006?
Keep it short and to the point. -2.19e+06. What is the difference between the Aid flow (current US$) in Greece in 2005 and the Aid flow (current US$) in Australia in 2006?
Ensure brevity in your answer.  -1.16e+06. What is the difference between the Aid flow (current US$) in Greece in 2005 and the Aid flow (current US$) in Finland in 2006?
Your response must be concise. -2.70e+06. What is the difference between the Aid flow (current US$) in Luxembourg in 2005 and the Aid flow (current US$) in Finland in 2006?
Offer a very short reply. -1.78e+06. What is the difference between the Aid flow (current US$) of Australia in 2005 and the Aid flow (current US$) of Finland in 2006?
Provide a short and direct response. -1.25e+06. What is the difference between the Aid flow (current US$) of Greece in 2005 and the Aid flow (current US$) of Luxembourg in 2007?
Give a very brief answer. -9.80e+05. What is the difference between the Aid flow (current US$) of Greece in 2005 and the Aid flow (current US$) of Australia in 2007?
Offer a very short reply. -6.75e+06. What is the difference between the Aid flow (current US$) of Greece in 2005 and the Aid flow (current US$) of Finland in 2007?
Keep it short and to the point. -3.35e+06. What is the difference between the Aid flow (current US$) in Luxembourg in 2005 and the Aid flow (current US$) in Australia in 2007?
Offer a very short reply. -5.83e+06. What is the difference between the Aid flow (current US$) of Luxembourg in 2005 and the Aid flow (current US$) of Finland in 2007?
Offer a terse response. -2.43e+06. What is the difference between the Aid flow (current US$) in Australia in 2005 and the Aid flow (current US$) in Finland in 2007?
Your response must be concise. -1.90e+06. What is the difference between the Aid flow (current US$) of Greece in 2005 and the Aid flow (current US$) of Luxembourg in 2008?
Make the answer very short. -4.44e+06. What is the difference between the Aid flow (current US$) of Greece in 2005 and the Aid flow (current US$) of Australia in 2008?
Ensure brevity in your answer.  1.52e+06. What is the difference between the Aid flow (current US$) in Greece in 2005 and the Aid flow (current US$) in Finland in 2008?
Your response must be concise. -5.24e+06. What is the difference between the Aid flow (current US$) in Luxembourg in 2005 and the Aid flow (current US$) in Australia in 2008?
Ensure brevity in your answer.  2.44e+06. What is the difference between the Aid flow (current US$) in Luxembourg in 2005 and the Aid flow (current US$) in Finland in 2008?
Ensure brevity in your answer.  -4.32e+06. What is the difference between the Aid flow (current US$) in Australia in 2005 and the Aid flow (current US$) in Finland in 2008?
Your answer should be compact. -3.79e+06. What is the difference between the Aid flow (current US$) of Greece in 2005 and the Aid flow (current US$) of Luxembourg in 2009?
Ensure brevity in your answer.  -4.25e+06. What is the difference between the Aid flow (current US$) of Greece in 2005 and the Aid flow (current US$) of Australia in 2009?
Provide a succinct answer. -9.87e+06. What is the difference between the Aid flow (current US$) of Greece in 2005 and the Aid flow (current US$) of Finland in 2009?
Your answer should be very brief. -7.58e+06. What is the difference between the Aid flow (current US$) in Luxembourg in 2005 and the Aid flow (current US$) in Australia in 2009?
Ensure brevity in your answer.  -8.95e+06. What is the difference between the Aid flow (current US$) of Luxembourg in 2005 and the Aid flow (current US$) of Finland in 2009?
Ensure brevity in your answer.  -6.66e+06. What is the difference between the Aid flow (current US$) of Australia in 2005 and the Aid flow (current US$) of Finland in 2009?
Your answer should be very brief. -6.13e+06. What is the difference between the Aid flow (current US$) in Greece in 2006 and the Aid flow (current US$) in Luxembourg in 2007?
Make the answer very short. 2.98e+06. What is the difference between the Aid flow (current US$) in Greece in 2006 and the Aid flow (current US$) in Australia in 2007?
Provide a succinct answer. -2.79e+06. What is the difference between the Aid flow (current US$) of Greece in 2006 and the Aid flow (current US$) of Finland in 2007?
Offer a very short reply. 6.10e+05. What is the difference between the Aid flow (current US$) in Luxembourg in 2006 and the Aid flow (current US$) in Australia in 2007?
Keep it short and to the point. -4.56e+06. What is the difference between the Aid flow (current US$) in Luxembourg in 2006 and the Aid flow (current US$) in Finland in 2007?
Your response must be concise. -1.16e+06. What is the difference between the Aid flow (current US$) in Australia in 2006 and the Aid flow (current US$) in Finland in 2007?
Offer a terse response. -2.19e+06. What is the difference between the Aid flow (current US$) of Greece in 2006 and the Aid flow (current US$) of Luxembourg in 2008?
Your answer should be compact. -4.80e+05. What is the difference between the Aid flow (current US$) of Greece in 2006 and the Aid flow (current US$) of Australia in 2008?
Keep it short and to the point. 5.48e+06. What is the difference between the Aid flow (current US$) of Greece in 2006 and the Aid flow (current US$) of Finland in 2008?
Ensure brevity in your answer.  -1.28e+06. What is the difference between the Aid flow (current US$) in Luxembourg in 2006 and the Aid flow (current US$) in Australia in 2008?
Your response must be concise. 3.71e+06. What is the difference between the Aid flow (current US$) in Luxembourg in 2006 and the Aid flow (current US$) in Finland in 2008?
Your answer should be compact. -3.05e+06. What is the difference between the Aid flow (current US$) of Australia in 2006 and the Aid flow (current US$) of Finland in 2008?
Your answer should be very brief. -4.08e+06. What is the difference between the Aid flow (current US$) of Greece in 2006 and the Aid flow (current US$) of Luxembourg in 2009?
Your response must be concise. -2.90e+05. What is the difference between the Aid flow (current US$) in Greece in 2006 and the Aid flow (current US$) in Australia in 2009?
Provide a short and direct response. -5.91e+06. What is the difference between the Aid flow (current US$) in Greece in 2006 and the Aid flow (current US$) in Finland in 2009?
Provide a short and direct response. -3.62e+06. What is the difference between the Aid flow (current US$) in Luxembourg in 2006 and the Aid flow (current US$) in Australia in 2009?
Provide a succinct answer. -7.68e+06. What is the difference between the Aid flow (current US$) in Luxembourg in 2006 and the Aid flow (current US$) in Finland in 2009?
Ensure brevity in your answer.  -5.39e+06. What is the difference between the Aid flow (current US$) of Australia in 2006 and the Aid flow (current US$) of Finland in 2009?
Your answer should be very brief. -6.42e+06. What is the difference between the Aid flow (current US$) of Greece in 2007 and the Aid flow (current US$) of Luxembourg in 2008?
Provide a succinct answer. -3.08e+06. What is the difference between the Aid flow (current US$) of Greece in 2007 and the Aid flow (current US$) of Australia in 2008?
Your answer should be compact. 2.88e+06. What is the difference between the Aid flow (current US$) of Greece in 2007 and the Aid flow (current US$) of Finland in 2008?
Your response must be concise. -3.88e+06. What is the difference between the Aid flow (current US$) of Luxembourg in 2007 and the Aid flow (current US$) of Australia in 2008?
Offer a terse response. 2.50e+06. What is the difference between the Aid flow (current US$) in Luxembourg in 2007 and the Aid flow (current US$) in Finland in 2008?
Offer a very short reply. -4.26e+06. What is the difference between the Aid flow (current US$) in Australia in 2007 and the Aid flow (current US$) in Finland in 2008?
Ensure brevity in your answer.  1.51e+06. What is the difference between the Aid flow (current US$) in Greece in 2007 and the Aid flow (current US$) in Luxembourg in 2009?
Your answer should be very brief. -2.89e+06. What is the difference between the Aid flow (current US$) of Greece in 2007 and the Aid flow (current US$) of Australia in 2009?
Provide a short and direct response. -8.51e+06. What is the difference between the Aid flow (current US$) of Greece in 2007 and the Aid flow (current US$) of Finland in 2009?
Make the answer very short. -6.22e+06. What is the difference between the Aid flow (current US$) of Luxembourg in 2007 and the Aid flow (current US$) of Australia in 2009?
Give a very brief answer. -8.89e+06. What is the difference between the Aid flow (current US$) in Luxembourg in 2007 and the Aid flow (current US$) in Finland in 2009?
Your response must be concise. -6.60e+06. What is the difference between the Aid flow (current US$) in Australia in 2007 and the Aid flow (current US$) in Finland in 2009?
Your response must be concise. -8.30e+05. What is the difference between the Aid flow (current US$) of Greece in 2008 and the Aid flow (current US$) of Luxembourg in 2009?
Offer a very short reply. 1.07e+06. What is the difference between the Aid flow (current US$) in Greece in 2008 and the Aid flow (current US$) in Australia in 2009?
Make the answer very short. -4.55e+06. What is the difference between the Aid flow (current US$) in Greece in 2008 and the Aid flow (current US$) in Finland in 2009?
Your answer should be compact. -2.26e+06. What is the difference between the Aid flow (current US$) of Luxembourg in 2008 and the Aid flow (current US$) of Australia in 2009?
Ensure brevity in your answer.  -5.43e+06. What is the difference between the Aid flow (current US$) of Luxembourg in 2008 and the Aid flow (current US$) of Finland in 2009?
Give a very brief answer. -3.14e+06. What is the difference between the Aid flow (current US$) of Australia in 2008 and the Aid flow (current US$) of Finland in 2009?
Make the answer very short. -9.10e+06. What is the average Aid flow (current US$) of Greece per year?
Offer a terse response. 4.39e+06. What is the average Aid flow (current US$) in Luxembourg per year?
Offer a very short reply. 3.65e+06. What is the average Aid flow (current US$) of Australia per year?
Your answer should be very brief. 3.82e+06. What is the average Aid flow (current US$) in Finland per year?
Your answer should be very brief. 4.97e+06. In the year 2001, what is the difference between the Aid flow (current US$) in Greece and Aid flow (current US$) in Luxembourg?
Your answer should be compact. 4.00e+04. In the year 2001, what is the difference between the Aid flow (current US$) in Greece and Aid flow (current US$) in Finland?
Offer a very short reply. -1.36e+06. In the year 2001, what is the difference between the Aid flow (current US$) of Luxembourg and Aid flow (current US$) of Australia?
Your response must be concise. 9.60e+05. In the year 2001, what is the difference between the Aid flow (current US$) of Luxembourg and Aid flow (current US$) of Finland?
Offer a terse response. -1.40e+06. In the year 2001, what is the difference between the Aid flow (current US$) in Australia and Aid flow (current US$) in Finland?
Make the answer very short. -2.36e+06. In the year 2002, what is the difference between the Aid flow (current US$) of Greece and Aid flow (current US$) of Luxembourg?
Give a very brief answer. -8.90e+05. In the year 2002, what is the difference between the Aid flow (current US$) of Greece and Aid flow (current US$) of Australia?
Keep it short and to the point. -1.12e+06. In the year 2002, what is the difference between the Aid flow (current US$) of Greece and Aid flow (current US$) of Finland?
Ensure brevity in your answer.  -3.00e+06. In the year 2002, what is the difference between the Aid flow (current US$) in Luxembourg and Aid flow (current US$) in Finland?
Offer a terse response. -2.11e+06. In the year 2002, what is the difference between the Aid flow (current US$) in Australia and Aid flow (current US$) in Finland?
Your answer should be compact. -1.88e+06. In the year 2003, what is the difference between the Aid flow (current US$) of Greece and Aid flow (current US$) of Luxembourg?
Make the answer very short. -2.28e+06. In the year 2003, what is the difference between the Aid flow (current US$) of Greece and Aid flow (current US$) of Australia?
Keep it short and to the point. 1.25e+06. In the year 2003, what is the difference between the Aid flow (current US$) of Greece and Aid flow (current US$) of Finland?
Offer a very short reply. -5.50e+05. In the year 2003, what is the difference between the Aid flow (current US$) in Luxembourg and Aid flow (current US$) in Australia?
Offer a very short reply. 3.53e+06. In the year 2003, what is the difference between the Aid flow (current US$) of Luxembourg and Aid flow (current US$) of Finland?
Keep it short and to the point. 1.73e+06. In the year 2003, what is the difference between the Aid flow (current US$) of Australia and Aid flow (current US$) of Finland?
Offer a terse response. -1.80e+06. In the year 2004, what is the difference between the Aid flow (current US$) of Greece and Aid flow (current US$) of Luxembourg?
Provide a succinct answer. 3.02e+06. In the year 2004, what is the difference between the Aid flow (current US$) of Greece and Aid flow (current US$) of Australia?
Give a very brief answer. 2.13e+06. In the year 2004, what is the difference between the Aid flow (current US$) of Greece and Aid flow (current US$) of Finland?
Offer a very short reply. 1.36e+06. In the year 2004, what is the difference between the Aid flow (current US$) in Luxembourg and Aid flow (current US$) in Australia?
Keep it short and to the point. -8.90e+05. In the year 2004, what is the difference between the Aid flow (current US$) of Luxembourg and Aid flow (current US$) of Finland?
Your response must be concise. -1.66e+06. In the year 2004, what is the difference between the Aid flow (current US$) in Australia and Aid flow (current US$) in Finland?
Give a very brief answer. -7.70e+05. In the year 2005, what is the difference between the Aid flow (current US$) in Greece and Aid flow (current US$) in Luxembourg?
Keep it short and to the point. -9.20e+05. In the year 2005, what is the difference between the Aid flow (current US$) of Greece and Aid flow (current US$) of Australia?
Provide a short and direct response. -1.45e+06. In the year 2005, what is the difference between the Aid flow (current US$) in Greece and Aid flow (current US$) in Finland?
Your answer should be very brief. -2.37e+06. In the year 2005, what is the difference between the Aid flow (current US$) of Luxembourg and Aid flow (current US$) of Australia?
Your response must be concise. -5.30e+05. In the year 2005, what is the difference between the Aid flow (current US$) in Luxembourg and Aid flow (current US$) in Finland?
Your answer should be compact. -1.45e+06. In the year 2005, what is the difference between the Aid flow (current US$) of Australia and Aid flow (current US$) of Finland?
Give a very brief answer. -9.20e+05. In the year 2006, what is the difference between the Aid flow (current US$) of Greece and Aid flow (current US$) of Luxembourg?
Give a very brief answer. 1.77e+06. In the year 2006, what is the difference between the Aid flow (current US$) in Greece and Aid flow (current US$) in Australia?
Provide a succinct answer. 2.80e+06. In the year 2006, what is the difference between the Aid flow (current US$) in Greece and Aid flow (current US$) in Finland?
Your response must be concise. 1.26e+06. In the year 2006, what is the difference between the Aid flow (current US$) in Luxembourg and Aid flow (current US$) in Australia?
Ensure brevity in your answer.  1.03e+06. In the year 2006, what is the difference between the Aid flow (current US$) in Luxembourg and Aid flow (current US$) in Finland?
Your answer should be very brief. -5.10e+05. In the year 2006, what is the difference between the Aid flow (current US$) of Australia and Aid flow (current US$) of Finland?
Ensure brevity in your answer.  -1.54e+06. In the year 2007, what is the difference between the Aid flow (current US$) of Greece and Aid flow (current US$) of Australia?
Your answer should be compact. -5.39e+06. In the year 2007, what is the difference between the Aid flow (current US$) in Greece and Aid flow (current US$) in Finland?
Ensure brevity in your answer.  -1.99e+06. In the year 2007, what is the difference between the Aid flow (current US$) in Luxembourg and Aid flow (current US$) in Australia?
Give a very brief answer. -5.77e+06. In the year 2007, what is the difference between the Aid flow (current US$) in Luxembourg and Aid flow (current US$) in Finland?
Keep it short and to the point. -2.37e+06. In the year 2007, what is the difference between the Aid flow (current US$) in Australia and Aid flow (current US$) in Finland?
Your answer should be very brief. 3.40e+06. In the year 2008, what is the difference between the Aid flow (current US$) of Greece and Aid flow (current US$) of Luxembourg?
Keep it short and to the point. 8.80e+05. In the year 2008, what is the difference between the Aid flow (current US$) in Greece and Aid flow (current US$) in Australia?
Your response must be concise. 6.84e+06. In the year 2008, what is the difference between the Aid flow (current US$) of Luxembourg and Aid flow (current US$) of Australia?
Provide a succinct answer. 5.96e+06. In the year 2008, what is the difference between the Aid flow (current US$) in Luxembourg and Aid flow (current US$) in Finland?
Your answer should be very brief. -8.00e+05. In the year 2008, what is the difference between the Aid flow (current US$) in Australia and Aid flow (current US$) in Finland?
Ensure brevity in your answer.  -6.76e+06. In the year 2009, what is the difference between the Aid flow (current US$) of Greece and Aid flow (current US$) of Luxembourg?
Offer a very short reply. 4.66e+06. In the year 2009, what is the difference between the Aid flow (current US$) in Greece and Aid flow (current US$) in Australia?
Your answer should be compact. -9.60e+05. In the year 2009, what is the difference between the Aid flow (current US$) of Greece and Aid flow (current US$) of Finland?
Keep it short and to the point. 1.33e+06. In the year 2009, what is the difference between the Aid flow (current US$) of Luxembourg and Aid flow (current US$) of Australia?
Your answer should be compact. -5.62e+06. In the year 2009, what is the difference between the Aid flow (current US$) of Luxembourg and Aid flow (current US$) of Finland?
Provide a succinct answer. -3.33e+06. In the year 2009, what is the difference between the Aid flow (current US$) in Australia and Aid flow (current US$) in Finland?
Make the answer very short. 2.29e+06. What is the ratio of the Aid flow (current US$) in Greece in 2001 to that in 2002?
Provide a succinct answer. 1.55. What is the ratio of the Aid flow (current US$) in Luxembourg in 2001 to that in 2002?
Provide a succinct answer. 0.9. What is the ratio of the Aid flow (current US$) of Australia in 2001 to that in 2002?
Provide a short and direct response. 0.41. What is the ratio of the Aid flow (current US$) in Finland in 2001 to that in 2002?
Keep it short and to the point. 0.78. What is the ratio of the Aid flow (current US$) of Greece in 2001 to that in 2003?
Offer a terse response. 0.99. What is the ratio of the Aid flow (current US$) of Luxembourg in 2001 to that in 2003?
Give a very brief answer. 0.46. What is the ratio of the Aid flow (current US$) of Australia in 2001 to that in 2003?
Keep it short and to the point. 1.32. What is the ratio of the Aid flow (current US$) of Finland in 2001 to that in 2003?
Keep it short and to the point. 1.31. What is the ratio of the Aid flow (current US$) of Greece in 2001 to that in 2004?
Provide a short and direct response. 0.35. What is the ratio of the Aid flow (current US$) of Luxembourg in 2001 to that in 2004?
Ensure brevity in your answer.  0.74. What is the ratio of the Aid flow (current US$) in Australia in 2001 to that in 2004?
Give a very brief answer. 0.28. What is the ratio of the Aid flow (current US$) of Finland in 2001 to that in 2004?
Your answer should be compact. 0.78. What is the ratio of the Aid flow (current US$) of Greece in 2001 to that in 2005?
Make the answer very short. 1.1. What is the ratio of the Aid flow (current US$) in Luxembourg in 2001 to that in 2005?
Your answer should be very brief. 0.71. What is the ratio of the Aid flow (current US$) in Australia in 2001 to that in 2005?
Your answer should be very brief. 0.3. What is the ratio of the Aid flow (current US$) of Finland in 2001 to that in 2005?
Provide a short and direct response. 0.8. What is the ratio of the Aid flow (current US$) of Greece in 2001 to that in 2006?
Ensure brevity in your answer.  0.34. What is the ratio of the Aid flow (current US$) in Luxembourg in 2001 to that in 2006?
Provide a short and direct response. 0.49. What is the ratio of the Aid flow (current US$) in Finland in 2001 to that in 2006?
Ensure brevity in your answer.  0.74. What is the ratio of the Aid flow (current US$) of Greece in 2001 to that in 2007?
Ensure brevity in your answer.  0.63. What is the ratio of the Aid flow (current US$) in Luxembourg in 2001 to that in 2007?
Your response must be concise. 0.7. What is the ratio of the Aid flow (current US$) of Australia in 2001 to that in 2007?
Your answer should be compact. 0.12. What is the ratio of the Aid flow (current US$) in Finland in 2001 to that in 2007?
Make the answer very short. 0.65. What is the ratio of the Aid flow (current US$) in Greece in 2001 to that in 2008?
Give a very brief answer. 0.28. What is the ratio of the Aid flow (current US$) in Luxembourg in 2001 to that in 2008?
Keep it short and to the point. 0.31. What is the ratio of the Aid flow (current US$) in Australia in 2001 to that in 2008?
Ensure brevity in your answer.  3.41. What is the ratio of the Aid flow (current US$) of Finland in 2001 to that in 2008?
Your answer should be compact. 0.48. What is the ratio of the Aid flow (current US$) of Greece in 2001 to that in 2009?
Your answer should be compact. 0.19. What is the ratio of the Aid flow (current US$) in Luxembourg in 2001 to that in 2009?
Ensure brevity in your answer.  0.32. What is the ratio of the Aid flow (current US$) of Australia in 2001 to that in 2009?
Offer a terse response. 0.08. What is the ratio of the Aid flow (current US$) in Finland in 2001 to that in 2009?
Keep it short and to the point. 0.36. What is the ratio of the Aid flow (current US$) in Greece in 2002 to that in 2003?
Your answer should be very brief. 0.64. What is the ratio of the Aid flow (current US$) of Luxembourg in 2002 to that in 2003?
Give a very brief answer. 0.51. What is the ratio of the Aid flow (current US$) in Finland in 2002 to that in 2003?
Offer a terse response. 1.68. What is the ratio of the Aid flow (current US$) in Greece in 2002 to that in 2004?
Give a very brief answer. 0.23. What is the ratio of the Aid flow (current US$) of Luxembourg in 2002 to that in 2004?
Make the answer very short. 0.83. What is the ratio of the Aid flow (current US$) in Australia in 2002 to that in 2004?
Your answer should be compact. 0.68. What is the ratio of the Aid flow (current US$) of Finland in 2002 to that in 2004?
Provide a succinct answer. 1. What is the ratio of the Aid flow (current US$) of Greece in 2002 to that in 2005?
Provide a succinct answer. 0.71. What is the ratio of the Aid flow (current US$) in Luxembourg in 2002 to that in 2005?
Your answer should be very brief. 0.79. What is the ratio of the Aid flow (current US$) in Australia in 2002 to that in 2005?
Make the answer very short. 0.74. What is the ratio of the Aid flow (current US$) in Finland in 2002 to that in 2005?
Give a very brief answer. 1.02. What is the ratio of the Aid flow (current US$) in Greece in 2002 to that in 2006?
Offer a terse response. 0.22. What is the ratio of the Aid flow (current US$) in Luxembourg in 2002 to that in 2006?
Give a very brief answer. 0.54. What is the ratio of the Aid flow (current US$) of Australia in 2002 to that in 2006?
Ensure brevity in your answer.  0.81. What is the ratio of the Aid flow (current US$) in Finland in 2002 to that in 2006?
Give a very brief answer. 0.95. What is the ratio of the Aid flow (current US$) in Greece in 2002 to that in 2007?
Offer a terse response. 0.4. What is the ratio of the Aid flow (current US$) in Luxembourg in 2002 to that in 2007?
Provide a short and direct response. 0.78. What is the ratio of the Aid flow (current US$) of Australia in 2002 to that in 2007?
Provide a succinct answer. 0.28. What is the ratio of the Aid flow (current US$) in Finland in 2002 to that in 2007?
Your answer should be compact. 0.83. What is the ratio of the Aid flow (current US$) in Greece in 2002 to that in 2008?
Offer a terse response. 0.18. What is the ratio of the Aid flow (current US$) of Luxembourg in 2002 to that in 2008?
Ensure brevity in your answer.  0.35. What is the ratio of the Aid flow (current US$) of Australia in 2002 to that in 2008?
Keep it short and to the point. 8.28. What is the ratio of the Aid flow (current US$) of Finland in 2002 to that in 2008?
Make the answer very short. 0.61. What is the ratio of the Aid flow (current US$) of Greece in 2002 to that in 2009?
Offer a very short reply. 0.12. What is the ratio of the Aid flow (current US$) of Luxembourg in 2002 to that in 2009?
Provide a succinct answer. 0.36. What is the ratio of the Aid flow (current US$) of Australia in 2002 to that in 2009?
Provide a succinct answer. 0.21. What is the ratio of the Aid flow (current US$) in Finland in 2002 to that in 2009?
Give a very brief answer. 0.46. What is the ratio of the Aid flow (current US$) in Greece in 2003 to that in 2004?
Give a very brief answer. 0.35. What is the ratio of the Aid flow (current US$) of Luxembourg in 2003 to that in 2004?
Offer a very short reply. 1.63. What is the ratio of the Aid flow (current US$) in Australia in 2003 to that in 2004?
Make the answer very short. 0.21. What is the ratio of the Aid flow (current US$) of Finland in 2003 to that in 2004?
Ensure brevity in your answer.  0.6. What is the ratio of the Aid flow (current US$) in Greece in 2003 to that in 2005?
Give a very brief answer. 1.1. What is the ratio of the Aid flow (current US$) in Luxembourg in 2003 to that in 2005?
Ensure brevity in your answer.  1.57. What is the ratio of the Aid flow (current US$) of Australia in 2003 to that in 2005?
Provide a short and direct response. 0.23. What is the ratio of the Aid flow (current US$) of Finland in 2003 to that in 2005?
Your answer should be very brief. 0.61. What is the ratio of the Aid flow (current US$) in Greece in 2003 to that in 2006?
Ensure brevity in your answer.  0.35. What is the ratio of the Aid flow (current US$) of Luxembourg in 2003 to that in 2006?
Your answer should be very brief. 1.07. What is the ratio of the Aid flow (current US$) of Australia in 2003 to that in 2006?
Your answer should be very brief. 0.25. What is the ratio of the Aid flow (current US$) in Finland in 2003 to that in 2006?
Your answer should be very brief. 0.57. What is the ratio of the Aid flow (current US$) in Greece in 2003 to that in 2007?
Ensure brevity in your answer.  0.63. What is the ratio of the Aid flow (current US$) of Luxembourg in 2003 to that in 2007?
Your answer should be compact. 1.53. What is the ratio of the Aid flow (current US$) of Australia in 2003 to that in 2007?
Your answer should be compact. 0.09. What is the ratio of the Aid flow (current US$) in Finland in 2003 to that in 2007?
Make the answer very short. 0.49. What is the ratio of the Aid flow (current US$) in Greece in 2003 to that in 2008?
Provide a short and direct response. 0.28. What is the ratio of the Aid flow (current US$) of Luxembourg in 2003 to that in 2008?
Your answer should be compact. 0.68. What is the ratio of the Aid flow (current US$) of Australia in 2003 to that in 2008?
Make the answer very short. 2.59. What is the ratio of the Aid flow (current US$) of Finland in 2003 to that in 2008?
Your response must be concise. 0.36. What is the ratio of the Aid flow (current US$) of Greece in 2003 to that in 2009?
Provide a short and direct response. 0.19. What is the ratio of the Aid flow (current US$) in Luxembourg in 2003 to that in 2009?
Provide a short and direct response. 0.71. What is the ratio of the Aid flow (current US$) in Australia in 2003 to that in 2009?
Offer a very short reply. 0.06. What is the ratio of the Aid flow (current US$) in Finland in 2003 to that in 2009?
Your answer should be compact. 0.27. What is the ratio of the Aid flow (current US$) of Greece in 2004 to that in 2005?
Provide a short and direct response. 3.12. What is the ratio of the Aid flow (current US$) in Luxembourg in 2004 to that in 2005?
Offer a terse response. 0.96. What is the ratio of the Aid flow (current US$) in Australia in 2004 to that in 2005?
Keep it short and to the point. 1.08. What is the ratio of the Aid flow (current US$) of Finland in 2004 to that in 2005?
Ensure brevity in your answer.  1.02. What is the ratio of the Aid flow (current US$) of Greece in 2004 to that in 2006?
Your answer should be compact. 0.98. What is the ratio of the Aid flow (current US$) of Luxembourg in 2004 to that in 2006?
Give a very brief answer. 0.66. What is the ratio of the Aid flow (current US$) in Australia in 2004 to that in 2006?
Give a very brief answer. 1.18. What is the ratio of the Aid flow (current US$) of Finland in 2004 to that in 2006?
Give a very brief answer. 0.95. What is the ratio of the Aid flow (current US$) of Greece in 2004 to that in 2007?
Make the answer very short. 1.78. What is the ratio of the Aid flow (current US$) of Luxembourg in 2004 to that in 2007?
Offer a very short reply. 0.94. What is the ratio of the Aid flow (current US$) of Australia in 2004 to that in 2007?
Offer a very short reply. 0.41. What is the ratio of the Aid flow (current US$) of Finland in 2004 to that in 2007?
Offer a very short reply. 0.83. What is the ratio of the Aid flow (current US$) of Greece in 2004 to that in 2008?
Your answer should be very brief. 0.79. What is the ratio of the Aid flow (current US$) of Luxembourg in 2004 to that in 2008?
Give a very brief answer. 0.42. What is the ratio of the Aid flow (current US$) of Australia in 2004 to that in 2008?
Keep it short and to the point. 12.1. What is the ratio of the Aid flow (current US$) of Finland in 2004 to that in 2008?
Provide a short and direct response. 0.61. What is the ratio of the Aid flow (current US$) in Greece in 2004 to that in 2009?
Ensure brevity in your answer.  0.53. What is the ratio of the Aid flow (current US$) of Luxembourg in 2004 to that in 2009?
Offer a terse response. 0.43. What is the ratio of the Aid flow (current US$) of Australia in 2004 to that in 2009?
Your answer should be very brief. 0.3. What is the ratio of the Aid flow (current US$) of Finland in 2004 to that in 2009?
Keep it short and to the point. 0.46. What is the ratio of the Aid flow (current US$) in Greece in 2005 to that in 2006?
Your response must be concise. 0.31. What is the ratio of the Aid flow (current US$) of Luxembourg in 2005 to that in 2006?
Your answer should be very brief. 0.68. What is the ratio of the Aid flow (current US$) of Australia in 2005 to that in 2006?
Keep it short and to the point. 1.1. What is the ratio of the Aid flow (current US$) in Finland in 2005 to that in 2006?
Ensure brevity in your answer.  0.93. What is the ratio of the Aid flow (current US$) in Greece in 2005 to that in 2007?
Provide a short and direct response. 0.57. What is the ratio of the Aid flow (current US$) of Luxembourg in 2005 to that in 2007?
Make the answer very short. 0.98. What is the ratio of the Aid flow (current US$) in Australia in 2005 to that in 2007?
Provide a short and direct response. 0.38. What is the ratio of the Aid flow (current US$) of Finland in 2005 to that in 2007?
Give a very brief answer. 0.81. What is the ratio of the Aid flow (current US$) of Greece in 2005 to that in 2008?
Make the answer very short. 0.25. What is the ratio of the Aid flow (current US$) in Luxembourg in 2005 to that in 2008?
Provide a succinct answer. 0.44. What is the ratio of the Aid flow (current US$) in Australia in 2005 to that in 2008?
Provide a short and direct response. 11.24. What is the ratio of the Aid flow (current US$) in Finland in 2005 to that in 2008?
Offer a very short reply. 0.59. What is the ratio of the Aid flow (current US$) of Greece in 2005 to that in 2009?
Keep it short and to the point. 0.17. What is the ratio of the Aid flow (current US$) of Luxembourg in 2005 to that in 2009?
Your answer should be very brief. 0.45. What is the ratio of the Aid flow (current US$) in Australia in 2005 to that in 2009?
Keep it short and to the point. 0.28. What is the ratio of the Aid flow (current US$) of Finland in 2005 to that in 2009?
Ensure brevity in your answer.  0.45. What is the ratio of the Aid flow (current US$) in Greece in 2006 to that in 2007?
Provide a short and direct response. 1.82. What is the ratio of the Aid flow (current US$) of Luxembourg in 2006 to that in 2007?
Keep it short and to the point. 1.43. What is the ratio of the Aid flow (current US$) in Australia in 2006 to that in 2007?
Offer a terse response. 0.35. What is the ratio of the Aid flow (current US$) in Finland in 2006 to that in 2007?
Give a very brief answer. 0.87. What is the ratio of the Aid flow (current US$) in Greece in 2006 to that in 2008?
Ensure brevity in your answer.  0.81. What is the ratio of the Aid flow (current US$) of Luxembourg in 2006 to that in 2008?
Your answer should be compact. 0.64. What is the ratio of the Aid flow (current US$) in Australia in 2006 to that in 2008?
Give a very brief answer. 10.24. What is the ratio of the Aid flow (current US$) in Finland in 2006 to that in 2008?
Provide a succinct answer. 0.64. What is the ratio of the Aid flow (current US$) of Greece in 2006 to that in 2009?
Provide a short and direct response. 0.54. What is the ratio of the Aid flow (current US$) of Luxembourg in 2006 to that in 2009?
Provide a short and direct response. 0.66. What is the ratio of the Aid flow (current US$) of Australia in 2006 to that in 2009?
Give a very brief answer. 0.25. What is the ratio of the Aid flow (current US$) in Finland in 2006 to that in 2009?
Offer a very short reply. 0.48. What is the ratio of the Aid flow (current US$) in Greece in 2007 to that in 2008?
Make the answer very short. 0.44. What is the ratio of the Aid flow (current US$) of Luxembourg in 2007 to that in 2008?
Your answer should be very brief. 0.45. What is the ratio of the Aid flow (current US$) in Australia in 2007 to that in 2008?
Your answer should be very brief. 29.52. What is the ratio of the Aid flow (current US$) in Finland in 2007 to that in 2008?
Offer a terse response. 0.73. What is the ratio of the Aid flow (current US$) of Greece in 2007 to that in 2009?
Offer a very short reply. 0.3. What is the ratio of the Aid flow (current US$) in Luxembourg in 2007 to that in 2009?
Give a very brief answer. 0.46. What is the ratio of the Aid flow (current US$) in Australia in 2007 to that in 2009?
Ensure brevity in your answer.  0.73. What is the ratio of the Aid flow (current US$) of Finland in 2007 to that in 2009?
Provide a succinct answer. 0.55. What is the ratio of the Aid flow (current US$) of Greece in 2008 to that in 2009?
Your answer should be very brief. 0.67. What is the ratio of the Aid flow (current US$) of Luxembourg in 2008 to that in 2009?
Your answer should be compact. 1.03. What is the ratio of the Aid flow (current US$) of Australia in 2008 to that in 2009?
Provide a short and direct response. 0.02. What is the ratio of the Aid flow (current US$) in Finland in 2008 to that in 2009?
Make the answer very short. 0.75. What is the difference between the highest and the second highest Aid flow (current US$) in Greece?
Provide a short and direct response. 3.59e+06. What is the difference between the highest and the second highest Aid flow (current US$) in Luxembourg?
Your answer should be very brief. 1.90e+05. What is the difference between the highest and the second highest Aid flow (current US$) in Australia?
Keep it short and to the point. 3.12e+06. What is the difference between the highest and the second highest Aid flow (current US$) in Finland?
Provide a succinct answer. 2.34e+06. What is the difference between the highest and the lowest Aid flow (current US$) of Greece?
Offer a terse response. 9.44e+06. What is the difference between the highest and the lowest Aid flow (current US$) in Luxembourg?
Ensure brevity in your answer.  4.30e+06. What is the difference between the highest and the lowest Aid flow (current US$) in Australia?
Provide a short and direct response. 1.14e+07. What is the difference between the highest and the lowest Aid flow (current US$) of Finland?
Keep it short and to the point. 6.84e+06. 